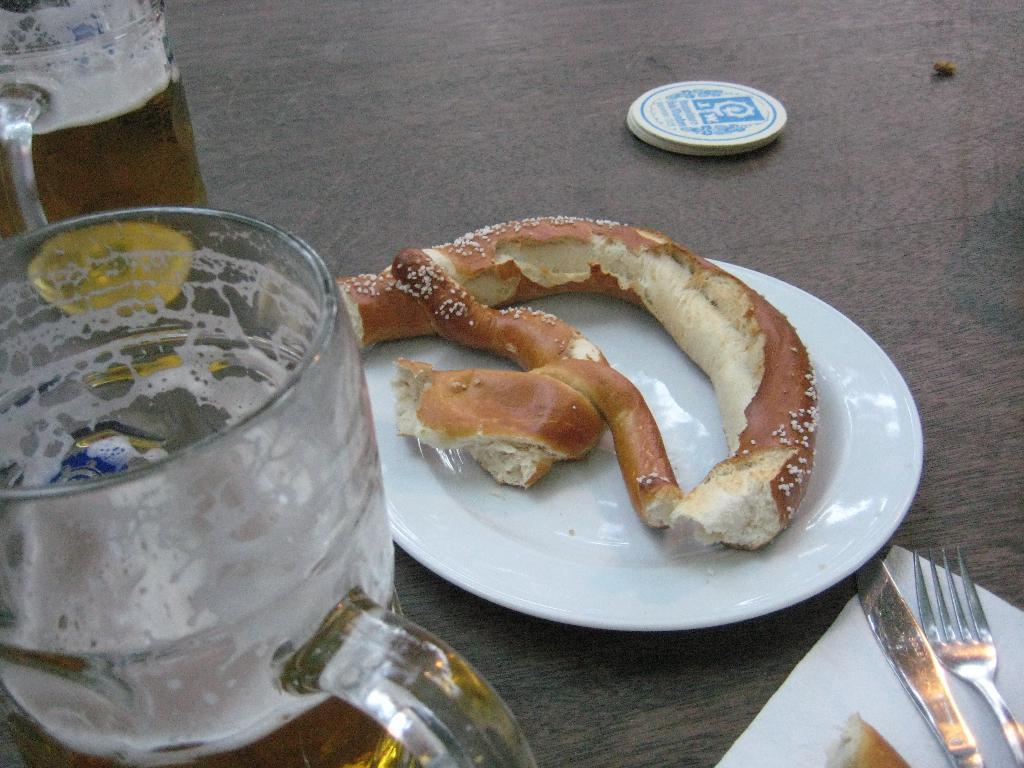What is on the plate that is visible in the image? There is a food item on the plate in the image. How many glasses can be seen in the image? There are two glasses in the image. What else is present on the table in the image? There are other objects on the table in the image. Where is the river flowing in the image? There is no river present in the image. What type of medical treatment is being administered in the image? There is no hospital or medical treatment present in the image. 